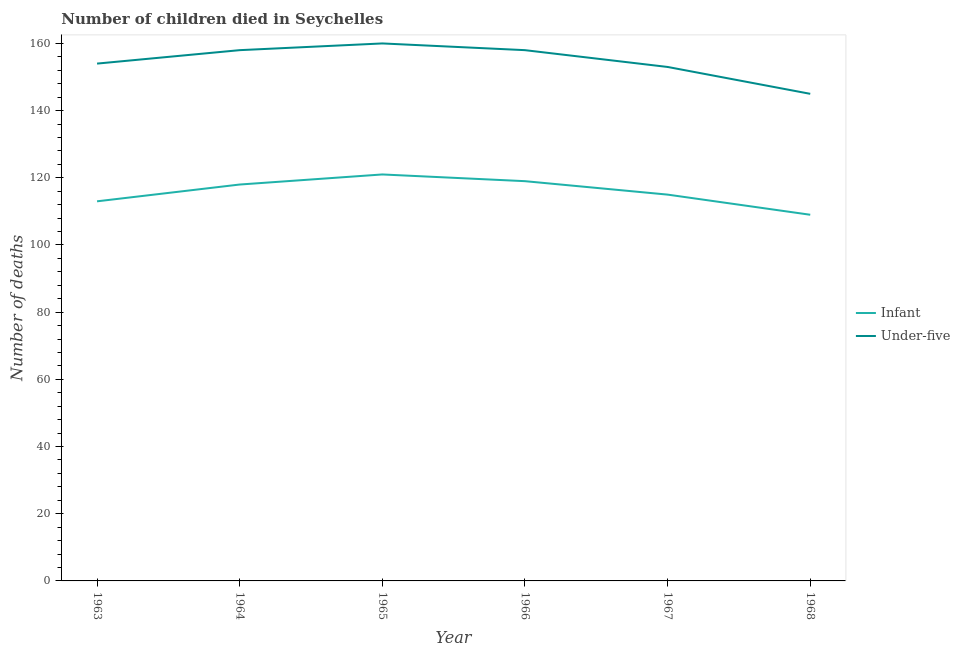Does the line corresponding to number of infant deaths intersect with the line corresponding to number of under-five deaths?
Make the answer very short. No. Is the number of lines equal to the number of legend labels?
Your answer should be compact. Yes. What is the number of under-five deaths in 1968?
Your answer should be very brief. 145. Across all years, what is the maximum number of under-five deaths?
Your answer should be very brief. 160. Across all years, what is the minimum number of under-five deaths?
Provide a succinct answer. 145. In which year was the number of infant deaths maximum?
Keep it short and to the point. 1965. In which year was the number of infant deaths minimum?
Offer a terse response. 1968. What is the total number of under-five deaths in the graph?
Make the answer very short. 928. What is the difference between the number of infant deaths in 1964 and that in 1966?
Your response must be concise. -1. What is the difference between the number of infant deaths in 1967 and the number of under-five deaths in 1963?
Offer a very short reply. -39. What is the average number of under-five deaths per year?
Provide a succinct answer. 154.67. In the year 1966, what is the difference between the number of under-five deaths and number of infant deaths?
Give a very brief answer. 39. In how many years, is the number of under-five deaths greater than 12?
Ensure brevity in your answer.  6. What is the ratio of the number of infant deaths in 1964 to that in 1966?
Make the answer very short. 0.99. What is the difference between the highest and the lowest number of under-five deaths?
Your answer should be very brief. 15. In how many years, is the number of infant deaths greater than the average number of infant deaths taken over all years?
Offer a very short reply. 3. Is the sum of the number of under-five deaths in 1964 and 1968 greater than the maximum number of infant deaths across all years?
Give a very brief answer. Yes. Is the number of under-five deaths strictly greater than the number of infant deaths over the years?
Ensure brevity in your answer.  Yes. Is the number of infant deaths strictly less than the number of under-five deaths over the years?
Ensure brevity in your answer.  Yes. How many years are there in the graph?
Give a very brief answer. 6. What is the difference between two consecutive major ticks on the Y-axis?
Provide a short and direct response. 20. Does the graph contain any zero values?
Your answer should be compact. No. Does the graph contain grids?
Your answer should be compact. No. Where does the legend appear in the graph?
Provide a short and direct response. Center right. How many legend labels are there?
Give a very brief answer. 2. What is the title of the graph?
Your answer should be compact. Number of children died in Seychelles. Does "Urban" appear as one of the legend labels in the graph?
Ensure brevity in your answer.  No. What is the label or title of the X-axis?
Provide a short and direct response. Year. What is the label or title of the Y-axis?
Offer a terse response. Number of deaths. What is the Number of deaths of Infant in 1963?
Provide a succinct answer. 113. What is the Number of deaths in Under-five in 1963?
Provide a short and direct response. 154. What is the Number of deaths in Infant in 1964?
Make the answer very short. 118. What is the Number of deaths in Under-five in 1964?
Make the answer very short. 158. What is the Number of deaths in Infant in 1965?
Your answer should be compact. 121. What is the Number of deaths in Under-five in 1965?
Your answer should be compact. 160. What is the Number of deaths of Infant in 1966?
Make the answer very short. 119. What is the Number of deaths in Under-five in 1966?
Provide a short and direct response. 158. What is the Number of deaths in Infant in 1967?
Make the answer very short. 115. What is the Number of deaths of Under-five in 1967?
Keep it short and to the point. 153. What is the Number of deaths in Infant in 1968?
Give a very brief answer. 109. What is the Number of deaths in Under-five in 1968?
Ensure brevity in your answer.  145. Across all years, what is the maximum Number of deaths of Infant?
Keep it short and to the point. 121. Across all years, what is the maximum Number of deaths of Under-five?
Ensure brevity in your answer.  160. Across all years, what is the minimum Number of deaths of Infant?
Offer a terse response. 109. Across all years, what is the minimum Number of deaths of Under-five?
Ensure brevity in your answer.  145. What is the total Number of deaths of Infant in the graph?
Make the answer very short. 695. What is the total Number of deaths in Under-five in the graph?
Your answer should be compact. 928. What is the difference between the Number of deaths of Infant in 1963 and that in 1964?
Your answer should be very brief. -5. What is the difference between the Number of deaths of Under-five in 1963 and that in 1964?
Make the answer very short. -4. What is the difference between the Number of deaths of Under-five in 1963 and that in 1966?
Your answer should be very brief. -4. What is the difference between the Number of deaths in Infant in 1963 and that in 1967?
Offer a terse response. -2. What is the difference between the Number of deaths in Under-five in 1963 and that in 1967?
Your response must be concise. 1. What is the difference between the Number of deaths of Infant in 1963 and that in 1968?
Provide a short and direct response. 4. What is the difference between the Number of deaths in Infant in 1964 and that in 1965?
Provide a short and direct response. -3. What is the difference between the Number of deaths in Under-five in 1964 and that in 1965?
Keep it short and to the point. -2. What is the difference between the Number of deaths in Under-five in 1964 and that in 1966?
Keep it short and to the point. 0. What is the difference between the Number of deaths in Under-five in 1964 and that in 1967?
Your answer should be compact. 5. What is the difference between the Number of deaths of Infant in 1965 and that in 1967?
Keep it short and to the point. 6. What is the difference between the Number of deaths of Under-five in 1965 and that in 1967?
Provide a succinct answer. 7. What is the difference between the Number of deaths in Infant in 1965 and that in 1968?
Make the answer very short. 12. What is the difference between the Number of deaths of Under-five in 1966 and that in 1967?
Give a very brief answer. 5. What is the difference between the Number of deaths of Infant in 1967 and that in 1968?
Your answer should be compact. 6. What is the difference between the Number of deaths of Under-five in 1967 and that in 1968?
Ensure brevity in your answer.  8. What is the difference between the Number of deaths in Infant in 1963 and the Number of deaths in Under-five in 1964?
Offer a very short reply. -45. What is the difference between the Number of deaths of Infant in 1963 and the Number of deaths of Under-five in 1965?
Your answer should be very brief. -47. What is the difference between the Number of deaths of Infant in 1963 and the Number of deaths of Under-five in 1966?
Give a very brief answer. -45. What is the difference between the Number of deaths of Infant in 1963 and the Number of deaths of Under-five in 1968?
Your answer should be very brief. -32. What is the difference between the Number of deaths of Infant in 1964 and the Number of deaths of Under-five in 1965?
Offer a very short reply. -42. What is the difference between the Number of deaths of Infant in 1964 and the Number of deaths of Under-five in 1966?
Ensure brevity in your answer.  -40. What is the difference between the Number of deaths of Infant in 1964 and the Number of deaths of Under-five in 1967?
Give a very brief answer. -35. What is the difference between the Number of deaths of Infant in 1964 and the Number of deaths of Under-five in 1968?
Provide a succinct answer. -27. What is the difference between the Number of deaths of Infant in 1965 and the Number of deaths of Under-five in 1966?
Your response must be concise. -37. What is the difference between the Number of deaths of Infant in 1965 and the Number of deaths of Under-five in 1967?
Offer a terse response. -32. What is the difference between the Number of deaths of Infant in 1966 and the Number of deaths of Under-five in 1967?
Ensure brevity in your answer.  -34. What is the difference between the Number of deaths in Infant in 1967 and the Number of deaths in Under-five in 1968?
Offer a terse response. -30. What is the average Number of deaths of Infant per year?
Keep it short and to the point. 115.83. What is the average Number of deaths in Under-five per year?
Make the answer very short. 154.67. In the year 1963, what is the difference between the Number of deaths of Infant and Number of deaths of Under-five?
Ensure brevity in your answer.  -41. In the year 1965, what is the difference between the Number of deaths in Infant and Number of deaths in Under-five?
Keep it short and to the point. -39. In the year 1966, what is the difference between the Number of deaths of Infant and Number of deaths of Under-five?
Make the answer very short. -39. In the year 1967, what is the difference between the Number of deaths of Infant and Number of deaths of Under-five?
Your answer should be compact. -38. In the year 1968, what is the difference between the Number of deaths of Infant and Number of deaths of Under-five?
Your response must be concise. -36. What is the ratio of the Number of deaths in Infant in 1963 to that in 1964?
Give a very brief answer. 0.96. What is the ratio of the Number of deaths of Under-five in 1963 to that in 1964?
Provide a short and direct response. 0.97. What is the ratio of the Number of deaths of Infant in 1963 to that in 1965?
Keep it short and to the point. 0.93. What is the ratio of the Number of deaths of Under-five in 1963 to that in 1965?
Provide a succinct answer. 0.96. What is the ratio of the Number of deaths in Infant in 1963 to that in 1966?
Your answer should be compact. 0.95. What is the ratio of the Number of deaths of Under-five in 1963 to that in 1966?
Provide a succinct answer. 0.97. What is the ratio of the Number of deaths of Infant in 1963 to that in 1967?
Provide a short and direct response. 0.98. What is the ratio of the Number of deaths of Under-five in 1963 to that in 1967?
Make the answer very short. 1.01. What is the ratio of the Number of deaths in Infant in 1963 to that in 1968?
Your answer should be very brief. 1.04. What is the ratio of the Number of deaths in Under-five in 1963 to that in 1968?
Offer a terse response. 1.06. What is the ratio of the Number of deaths of Infant in 1964 to that in 1965?
Your answer should be compact. 0.98. What is the ratio of the Number of deaths in Under-five in 1964 to that in 1965?
Provide a short and direct response. 0.99. What is the ratio of the Number of deaths in Under-five in 1964 to that in 1966?
Provide a short and direct response. 1. What is the ratio of the Number of deaths of Infant in 1964 to that in 1967?
Ensure brevity in your answer.  1.03. What is the ratio of the Number of deaths of Under-five in 1964 to that in 1967?
Your response must be concise. 1.03. What is the ratio of the Number of deaths in Infant in 1964 to that in 1968?
Give a very brief answer. 1.08. What is the ratio of the Number of deaths in Under-five in 1964 to that in 1968?
Your response must be concise. 1.09. What is the ratio of the Number of deaths in Infant in 1965 to that in 1966?
Your response must be concise. 1.02. What is the ratio of the Number of deaths of Under-five in 1965 to that in 1966?
Offer a very short reply. 1.01. What is the ratio of the Number of deaths of Infant in 1965 to that in 1967?
Your answer should be compact. 1.05. What is the ratio of the Number of deaths of Under-five in 1965 to that in 1967?
Keep it short and to the point. 1.05. What is the ratio of the Number of deaths in Infant in 1965 to that in 1968?
Your answer should be very brief. 1.11. What is the ratio of the Number of deaths of Under-five in 1965 to that in 1968?
Provide a short and direct response. 1.1. What is the ratio of the Number of deaths in Infant in 1966 to that in 1967?
Provide a succinct answer. 1.03. What is the ratio of the Number of deaths of Under-five in 1966 to that in 1967?
Your response must be concise. 1.03. What is the ratio of the Number of deaths in Infant in 1966 to that in 1968?
Your response must be concise. 1.09. What is the ratio of the Number of deaths in Under-five in 1966 to that in 1968?
Your answer should be compact. 1.09. What is the ratio of the Number of deaths of Infant in 1967 to that in 1968?
Your response must be concise. 1.05. What is the ratio of the Number of deaths in Under-five in 1967 to that in 1968?
Your answer should be compact. 1.06. What is the difference between the highest and the second highest Number of deaths of Infant?
Make the answer very short. 2. What is the difference between the highest and the second highest Number of deaths of Under-five?
Your answer should be very brief. 2. What is the difference between the highest and the lowest Number of deaths of Infant?
Offer a very short reply. 12. What is the difference between the highest and the lowest Number of deaths of Under-five?
Offer a terse response. 15. 